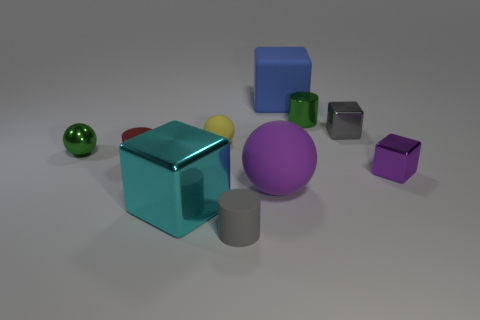What number of small cubes have the same material as the large cyan object?
Your answer should be very brief. 2. Is the purple block the same size as the purple sphere?
Offer a very short reply. No. Is there any other thing of the same color as the large shiny block?
Give a very brief answer. No. What is the shape of the rubber object that is both behind the small red metal cylinder and in front of the rubber cube?
Make the answer very short. Sphere. What size is the cube behind the small gray shiny object?
Offer a terse response. Large. What number of gray matte cylinders are right of the green thing left of the metallic cylinder that is right of the blue thing?
Your response must be concise. 1. There is a tiny metallic ball; are there any small objects in front of it?
Provide a short and direct response. Yes. How many other objects are there of the same size as the yellow matte sphere?
Give a very brief answer. 6. The cylinder that is to the right of the big metal cube and behind the big purple sphere is made of what material?
Your answer should be compact. Metal. There is a green metal object left of the big blue cube; is its shape the same as the tiny green thing that is right of the red cylinder?
Keep it short and to the point. No. 